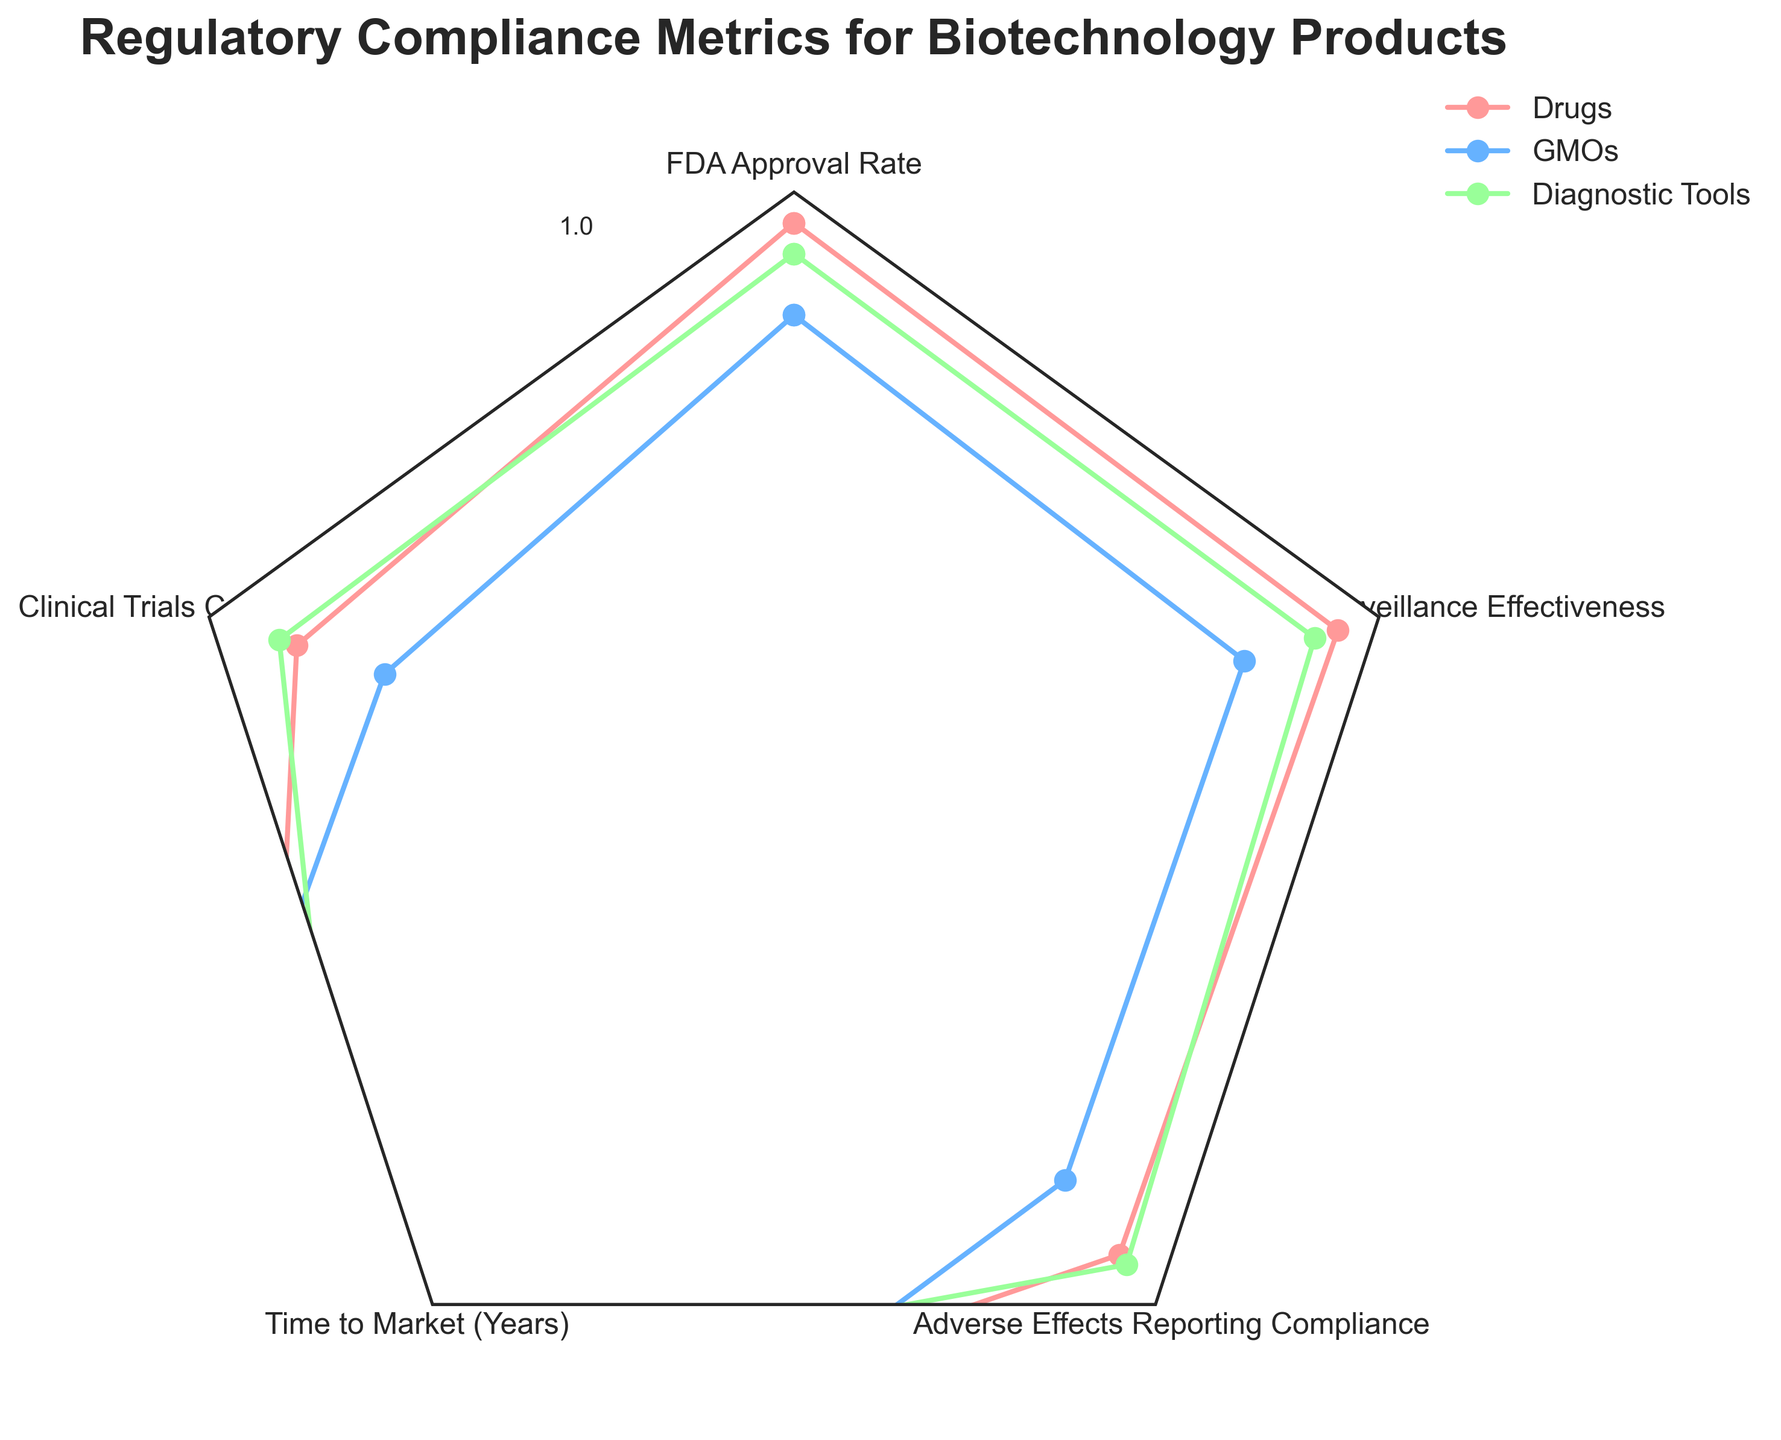What are the five regulatory compliance metrics displayed in the figure? The radar chart includes five different compliance metrics, which can be identified from the labels at each vertex of the chart. These labels represent different aspects of regulatory compliance that are being measured. The metrics shown on the radar chart are FDA Approval Rate, Clinical Trials Completed, Time to Market (Years), Adverse Effects Reporting Compliance, and Post-Market Surveillance Effectiveness.
Answer: FDA Approval Rate, Clinical Trials Completed, Time to Market (Years), Adverse Effects Reporting Compliance, Post-Market Surveillance Effectiveness Which product category has the highest FDA Approval Rate? By examining the vertex labeled "FDA Approval Rate," one can see the lengths of the lines corresponding to each product category. The product category whose line extends the furthest towards the outer edge of the chart has the highest approval rate in this category. Among Drugs, GMOs, and Diagnostic Tools, the line for Drugs extends the furthest out, indicating it has the highest FDA Approval Rate at 0.95.
Answer: Drugs Among the three product categories, which one has the shortest average Time to Market? The vertex labeled "Time to Market (Years)" shows the values for each category. To find the shortest average Time to Market, look for the line closest to the center of the chart, as a shorter distance from the center indicates fewer years. The Diagnostic Tools category, with its line closest to the center at 1.2 years, indicates it has the shortest Time to Market.
Answer: Diagnostic Tools How do the Post-Market Surveillance Effectiveness scores compare among the three categories? Examine the lengths of the lines on the vertex labeled "Post-Market Surveillance Effectiveness" for each product category. Each line’s length, from center to edge, represents the score. The Drugs category has a score of 0.93, GMOs have 0.77, and Diagnostic Tools have 0.89. Hence, Drugs have the highest, followed by Diagnostic Tools, and then GMOs.
Answer: Drugs > Diagnostic Tools > GMOs Which product category has the most consistent performance across all regulatory compliance metrics? Consistent performance can be identified by observing how close each line is to forming a balanced shape without extreme values. By visually assessing the radar chart, the Drugs category shows the closest values across all vertices, thus displaying the most consistency in performance.
Answer: Drugs What is the range of values for Adverse Effects Reporting Compliance across all product categories? The values for Adverse Effects Reporting Compliance can be identified by locating the lines on the corresponding vertex. The values are 0.90 for Drugs, 0.75 for GMOs, and 0.92 for Diagnostic Tools. Therefore, the range, which is the difference between the highest and lowest values, is 0.92 - 0.75 = 0.17.
Answer: 0.17 Which product category requires the longest average Time to Market, and by how much is it longer than the shortest? The vertex labeled "Time to Market (Years)" indicates the duration for each category. Drugs take 1.5 years, GMOs take 2.5 years, and Diagnostic Tools take 1.2 years. GMOs have the longest average Time to Market at 2.5 years. The difference between the longest (2.5 years) and shortest (1.2 years) Time to Market is 2.5 - 1.2 = 1.3 years.
Answer: GMOs, 1.3 years Is there any metric where Diagnostic Tools outperform both Drugs and GMOs? To determine this, compare the values for Diagnostic Tools against the values for Drugs and GMOs for each metric. For Post-Market Surveillance Effectiveness, Diagnostic Tools score 0.89, Drugs score 0.93, and GMOs score 0.77. Diagnostic Tools outperform both on Adverse Effects Reporting Compliance with a score of 0.92 compared to 0.90 for Drugs and 0.75 for GMOs.
Answer: Yes 